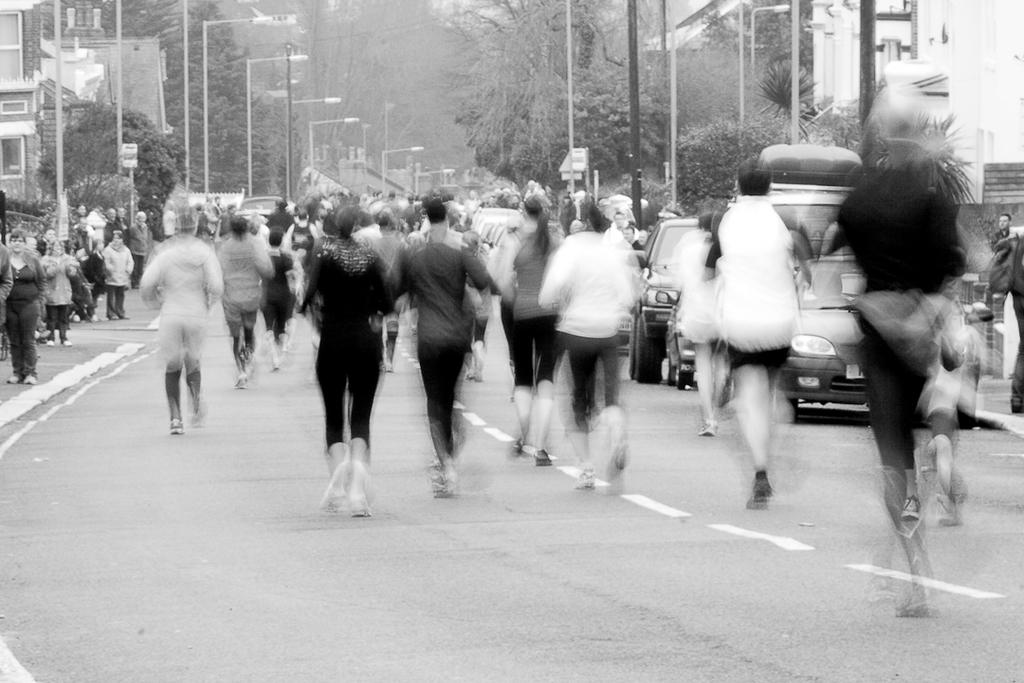What is the color scheme of the image? The image is black and white. What can be seen on the road in the image? There are vehicles and persons on the road. What structures are visible in the image? There are poles, trees, and buildings in the image. Where is the jail located in the image? There is no jail present in the image. What type of stick can be seen in the image? There is no stick present in the image. 